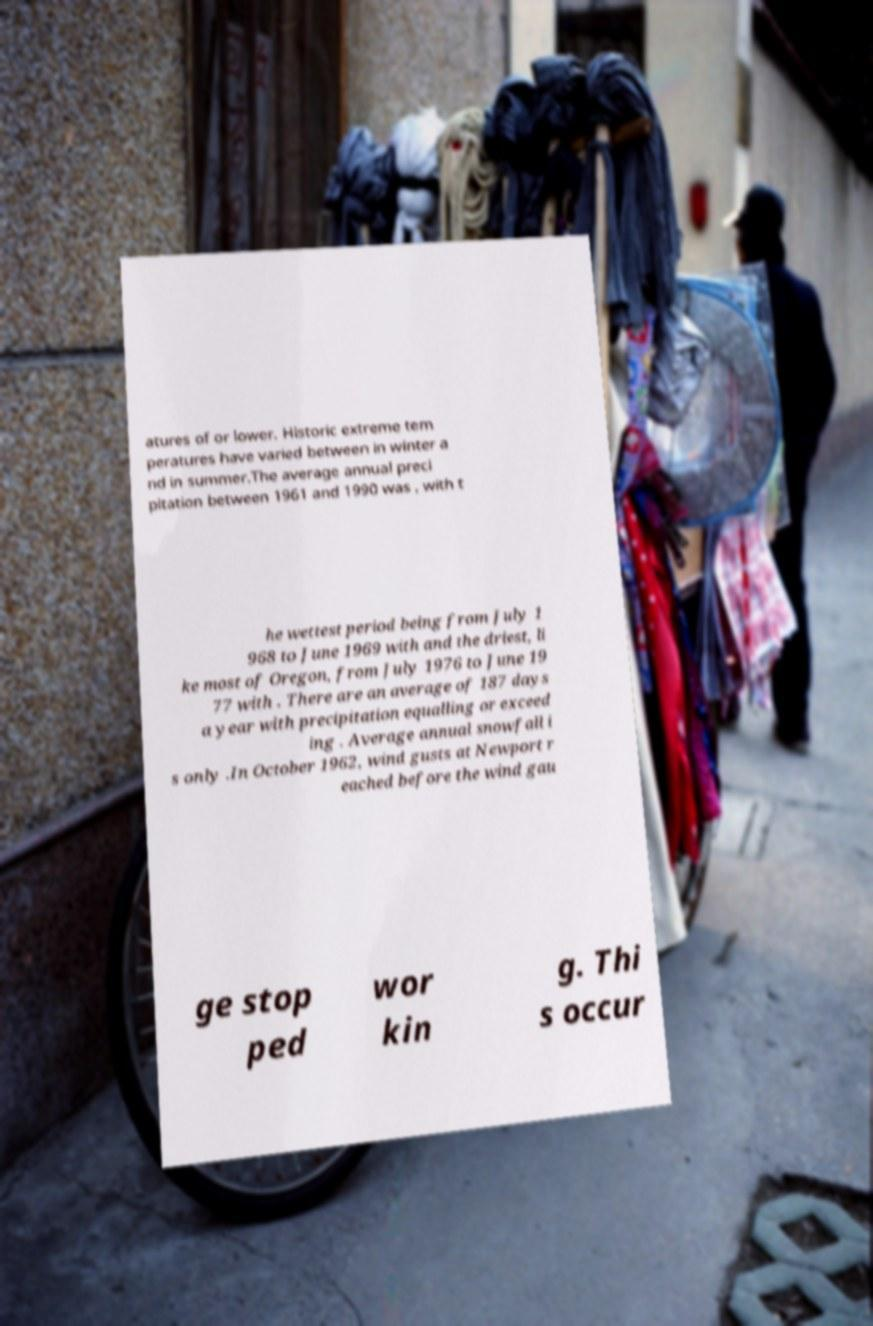Can you accurately transcribe the text from the provided image for me? atures of or lower. Historic extreme tem peratures have varied between in winter a nd in summer.The average annual preci pitation between 1961 and 1990 was , with t he wettest period being from July 1 968 to June 1969 with and the driest, li ke most of Oregon, from July 1976 to June 19 77 with . There are an average of 187 days a year with precipitation equalling or exceed ing . Average annual snowfall i s only .In October 1962, wind gusts at Newport r eached before the wind gau ge stop ped wor kin g. Thi s occur 